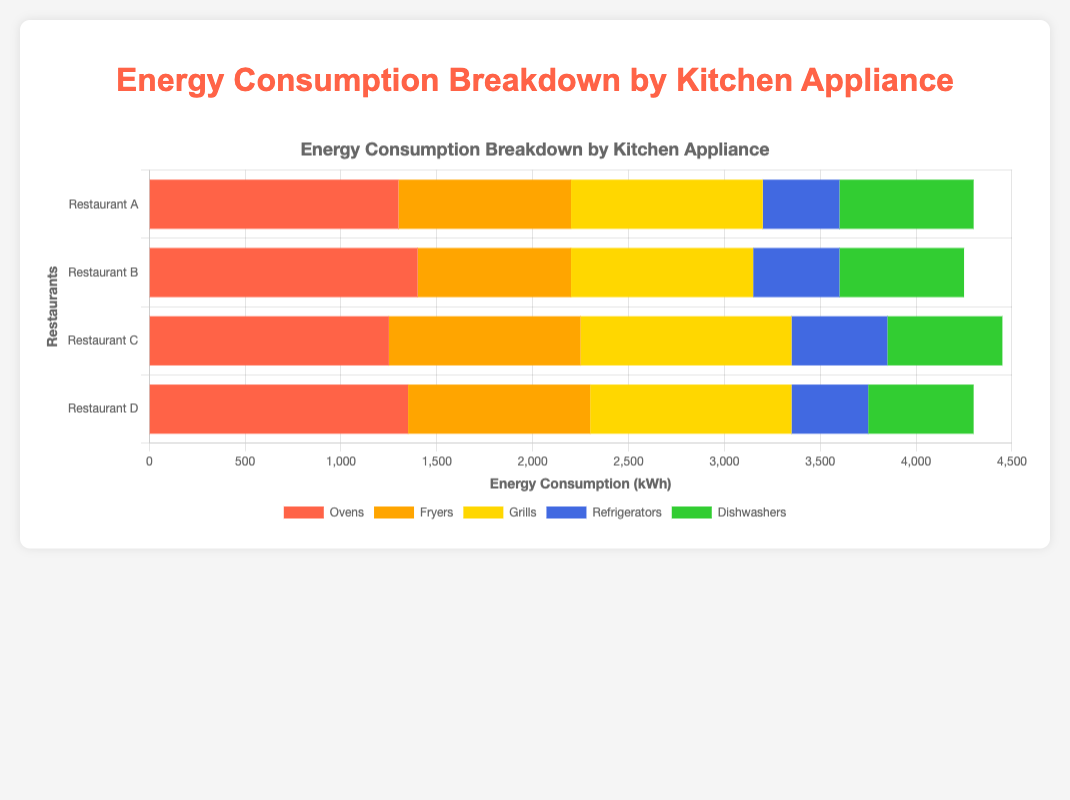What is the total energy consumption by ovens across all restaurants? Add up the energy consumption by ovens in all four restaurants: 1300 (Restaurant A) + 1400 (Restaurant B) + 1250 (Restaurant C) + 1350 (Restaurant D) = 5300 kWh
Answer: 5300 kWh Which restaurant has the highest energy consumption for grills? Compare the grill energy consumption across all restaurants: 1000 (Restaurant A), 950 (Restaurant B), 1100 (Restaurant C), 1050 (Restaurant D). The highest value is 1100 in Restaurant C
Answer: Restaurant C Which appliance has the lowest energy consumption in Restaurant B? Compare the energy consumption of different appliances in Restaurant B: 1400 (Ovens), 800 (Fryers), 950 (Grills), 450 (Refrigerators), 650 (Dishwashers). The lowest value is 450 for refrigerators
Answer: Refrigerators What is the average energy consumption for dishwashers across all restaurants? Add up the energy consumption for dishwashers across all restaurants and divide by the number of restaurants: (700 + 650 + 600 + 550) / 4 = 2500 / 4 = 625 kWh
Answer: 625 kWh Which appliance consumes more energy in Restaurant A: fryers or dishwashers? Compare the energy consumption for fryers (900 kWh) and dishwashers (700 kWh) in Restaurant A. Fryers consume more energy
Answer: Fryers What is the combined energy consumption of refrigerators and dishwashers in Restaurant D? Add up the energy consumption for refrigerators and dishwashers in Restaurant D: 400 (Refrigerators) + 550 (Dishwashers) = 950 kWh
Answer: 950 kWh How does the energy consumption of dishwashers in Restaurant C compare to that in Restaurant D? Compare the energy consumption of dishwashers in Restaurant C (600 kWh) and Restaurant D (550 kWh). Dishwashers in Restaurant C consume more energy
Answer: Restaurant C Which appliance has the greatest range of energy consumption across all restaurants? Calculate the range for each appliance (maximum - minimum): 
- Ovens: 1400 - 1250 = 150 kWh
- Fryers: 1000 - 800 = 200 kWh
- Grills: 1100 - 950 = 150 kWh
- Refrigerators: 500 - 400 = 100 kWh
- Dishwashers: 700 - 550 = 150 kWh
The greatest range is for fryers
Answer: Fryers What percentage of the total energy consumption in Restaurant B is due to refrigerators? Calculate the total energy consumption in Restaurant B and then the percentage due to refrigerators:
Total energy in Restaurant B: 1400 (Ovens) + 800 (Fryers) + 950 (Grills) + 450 (Refrigerators) + 650 (Dishwashers) = 4250 kWh
Percentage for refrigerators: (450 / 4250) * 100 ≈ 10.59%
Answer: ~10.59% Which restaurant has the lowest total energy consumption? Calculate the total energy consumption for each restaurant:
- Restaurant A: 1300 + 900 + 1000 + 400 + 700 = 4300 kWh
- Restaurant B: 1400 + 800 + 950 + 450 + 650 = 4250 kWh
- Restaurant C: 1250 + 1000 + 1100 + 500 + 600 = 4450 kWh
- Restaurant D: 1350 + 950 + 1050 + 400 + 550 = 4300 kWh
Restaurant B has the lowest total energy consumption
Answer: Restaurant B 